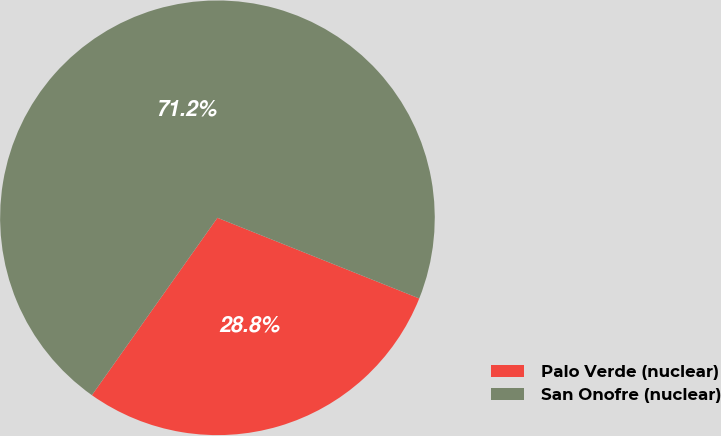<chart> <loc_0><loc_0><loc_500><loc_500><pie_chart><fcel>Palo Verde (nuclear)<fcel>San Onofre (nuclear)<nl><fcel>28.75%<fcel>71.25%<nl></chart> 